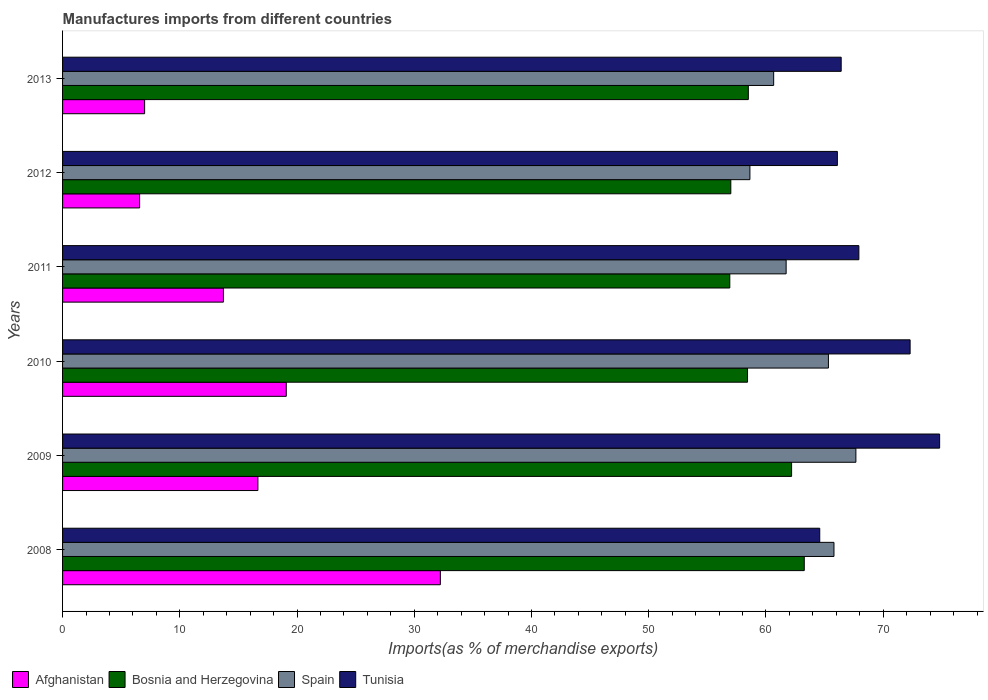How many different coloured bars are there?
Keep it short and to the point. 4. Are the number of bars on each tick of the Y-axis equal?
Make the answer very short. Yes. How many bars are there on the 4th tick from the bottom?
Your response must be concise. 4. What is the percentage of imports to different countries in Bosnia and Herzegovina in 2008?
Keep it short and to the point. 63.27. Across all years, what is the maximum percentage of imports to different countries in Afghanistan?
Make the answer very short. 32.23. Across all years, what is the minimum percentage of imports to different countries in Spain?
Your answer should be compact. 58.63. In which year was the percentage of imports to different countries in Bosnia and Herzegovina maximum?
Your answer should be very brief. 2008. In which year was the percentage of imports to different countries in Bosnia and Herzegovina minimum?
Offer a terse response. 2011. What is the total percentage of imports to different countries in Afghanistan in the graph?
Keep it short and to the point. 95.26. What is the difference between the percentage of imports to different countries in Tunisia in 2008 and that in 2009?
Provide a short and direct response. -10.23. What is the difference between the percentage of imports to different countries in Bosnia and Herzegovina in 2013 and the percentage of imports to different countries in Afghanistan in 2012?
Offer a terse response. 51.92. What is the average percentage of imports to different countries in Spain per year?
Offer a very short reply. 63.3. In the year 2009, what is the difference between the percentage of imports to different countries in Afghanistan and percentage of imports to different countries in Tunisia?
Ensure brevity in your answer.  -58.15. In how many years, is the percentage of imports to different countries in Afghanistan greater than 54 %?
Your answer should be very brief. 0. What is the ratio of the percentage of imports to different countries in Spain in 2009 to that in 2012?
Offer a very short reply. 1.15. Is the difference between the percentage of imports to different countries in Afghanistan in 2009 and 2013 greater than the difference between the percentage of imports to different countries in Tunisia in 2009 and 2013?
Give a very brief answer. Yes. What is the difference between the highest and the second highest percentage of imports to different countries in Spain?
Your answer should be compact. 1.87. What is the difference between the highest and the lowest percentage of imports to different countries in Spain?
Your answer should be compact. 9.04. In how many years, is the percentage of imports to different countries in Afghanistan greater than the average percentage of imports to different countries in Afghanistan taken over all years?
Offer a terse response. 3. Is the sum of the percentage of imports to different countries in Tunisia in 2010 and 2013 greater than the maximum percentage of imports to different countries in Spain across all years?
Your response must be concise. Yes. Is it the case that in every year, the sum of the percentage of imports to different countries in Afghanistan and percentage of imports to different countries in Bosnia and Herzegovina is greater than the sum of percentage of imports to different countries in Spain and percentage of imports to different countries in Tunisia?
Your answer should be very brief. No. What does the 4th bar from the top in 2010 represents?
Give a very brief answer. Afghanistan. Is it the case that in every year, the sum of the percentage of imports to different countries in Bosnia and Herzegovina and percentage of imports to different countries in Tunisia is greater than the percentage of imports to different countries in Spain?
Give a very brief answer. Yes. How many years are there in the graph?
Keep it short and to the point. 6. Are the values on the major ticks of X-axis written in scientific E-notation?
Your answer should be very brief. No. Does the graph contain grids?
Keep it short and to the point. No. Where does the legend appear in the graph?
Keep it short and to the point. Bottom left. How are the legend labels stacked?
Provide a succinct answer. Horizontal. What is the title of the graph?
Make the answer very short. Manufactures imports from different countries. What is the label or title of the X-axis?
Ensure brevity in your answer.  Imports(as % of merchandise exports). What is the Imports(as % of merchandise exports) of Afghanistan in 2008?
Your answer should be compact. 32.23. What is the Imports(as % of merchandise exports) of Bosnia and Herzegovina in 2008?
Offer a terse response. 63.27. What is the Imports(as % of merchandise exports) in Spain in 2008?
Ensure brevity in your answer.  65.8. What is the Imports(as % of merchandise exports) of Tunisia in 2008?
Your answer should be compact. 64.59. What is the Imports(as % of merchandise exports) in Afghanistan in 2009?
Offer a very short reply. 16.66. What is the Imports(as % of merchandise exports) in Bosnia and Herzegovina in 2009?
Ensure brevity in your answer.  62.19. What is the Imports(as % of merchandise exports) of Spain in 2009?
Make the answer very short. 67.67. What is the Imports(as % of merchandise exports) in Tunisia in 2009?
Offer a very short reply. 74.81. What is the Imports(as % of merchandise exports) in Afghanistan in 2010?
Provide a succinct answer. 19.08. What is the Imports(as % of merchandise exports) in Bosnia and Herzegovina in 2010?
Provide a succinct answer. 58.43. What is the Imports(as % of merchandise exports) in Spain in 2010?
Keep it short and to the point. 65.33. What is the Imports(as % of merchandise exports) in Tunisia in 2010?
Your response must be concise. 72.29. What is the Imports(as % of merchandise exports) in Afghanistan in 2011?
Provide a succinct answer. 13.72. What is the Imports(as % of merchandise exports) in Bosnia and Herzegovina in 2011?
Give a very brief answer. 56.91. What is the Imports(as % of merchandise exports) of Spain in 2011?
Offer a very short reply. 61.72. What is the Imports(as % of merchandise exports) in Tunisia in 2011?
Offer a very short reply. 67.92. What is the Imports(as % of merchandise exports) in Afghanistan in 2012?
Your answer should be very brief. 6.57. What is the Imports(as % of merchandise exports) in Bosnia and Herzegovina in 2012?
Offer a very short reply. 57. What is the Imports(as % of merchandise exports) of Spain in 2012?
Offer a terse response. 58.63. What is the Imports(as % of merchandise exports) of Tunisia in 2012?
Provide a succinct answer. 66.09. What is the Imports(as % of merchandise exports) in Afghanistan in 2013?
Offer a terse response. 7. What is the Imports(as % of merchandise exports) in Bosnia and Herzegovina in 2013?
Provide a short and direct response. 58.49. What is the Imports(as % of merchandise exports) in Spain in 2013?
Ensure brevity in your answer.  60.66. What is the Imports(as % of merchandise exports) of Tunisia in 2013?
Your answer should be very brief. 66.42. Across all years, what is the maximum Imports(as % of merchandise exports) of Afghanistan?
Give a very brief answer. 32.23. Across all years, what is the maximum Imports(as % of merchandise exports) in Bosnia and Herzegovina?
Offer a terse response. 63.27. Across all years, what is the maximum Imports(as % of merchandise exports) in Spain?
Ensure brevity in your answer.  67.67. Across all years, what is the maximum Imports(as % of merchandise exports) of Tunisia?
Provide a short and direct response. 74.81. Across all years, what is the minimum Imports(as % of merchandise exports) of Afghanistan?
Make the answer very short. 6.57. Across all years, what is the minimum Imports(as % of merchandise exports) of Bosnia and Herzegovina?
Keep it short and to the point. 56.91. Across all years, what is the minimum Imports(as % of merchandise exports) in Spain?
Your answer should be compact. 58.63. Across all years, what is the minimum Imports(as % of merchandise exports) in Tunisia?
Keep it short and to the point. 64.59. What is the total Imports(as % of merchandise exports) in Afghanistan in the graph?
Keep it short and to the point. 95.26. What is the total Imports(as % of merchandise exports) in Bosnia and Herzegovina in the graph?
Make the answer very short. 356.29. What is the total Imports(as % of merchandise exports) of Spain in the graph?
Make the answer very short. 379.8. What is the total Imports(as % of merchandise exports) of Tunisia in the graph?
Provide a short and direct response. 412.12. What is the difference between the Imports(as % of merchandise exports) of Afghanistan in 2008 and that in 2009?
Make the answer very short. 15.56. What is the difference between the Imports(as % of merchandise exports) in Bosnia and Herzegovina in 2008 and that in 2009?
Ensure brevity in your answer.  1.08. What is the difference between the Imports(as % of merchandise exports) of Spain in 2008 and that in 2009?
Offer a very short reply. -1.87. What is the difference between the Imports(as % of merchandise exports) in Tunisia in 2008 and that in 2009?
Your answer should be very brief. -10.23. What is the difference between the Imports(as % of merchandise exports) in Afghanistan in 2008 and that in 2010?
Provide a short and direct response. 13.14. What is the difference between the Imports(as % of merchandise exports) in Bosnia and Herzegovina in 2008 and that in 2010?
Offer a terse response. 4.84. What is the difference between the Imports(as % of merchandise exports) in Spain in 2008 and that in 2010?
Ensure brevity in your answer.  0.47. What is the difference between the Imports(as % of merchandise exports) in Tunisia in 2008 and that in 2010?
Your answer should be very brief. -7.71. What is the difference between the Imports(as % of merchandise exports) of Afghanistan in 2008 and that in 2011?
Ensure brevity in your answer.  18.5. What is the difference between the Imports(as % of merchandise exports) of Bosnia and Herzegovina in 2008 and that in 2011?
Your answer should be very brief. 6.35. What is the difference between the Imports(as % of merchandise exports) of Spain in 2008 and that in 2011?
Your answer should be very brief. 4.08. What is the difference between the Imports(as % of merchandise exports) in Tunisia in 2008 and that in 2011?
Make the answer very short. -3.34. What is the difference between the Imports(as % of merchandise exports) of Afghanistan in 2008 and that in 2012?
Your response must be concise. 25.65. What is the difference between the Imports(as % of merchandise exports) of Bosnia and Herzegovina in 2008 and that in 2012?
Your answer should be compact. 6.27. What is the difference between the Imports(as % of merchandise exports) in Spain in 2008 and that in 2012?
Offer a terse response. 7.17. What is the difference between the Imports(as % of merchandise exports) of Tunisia in 2008 and that in 2012?
Your response must be concise. -1.5. What is the difference between the Imports(as % of merchandise exports) in Afghanistan in 2008 and that in 2013?
Your answer should be compact. 25.23. What is the difference between the Imports(as % of merchandise exports) in Bosnia and Herzegovina in 2008 and that in 2013?
Keep it short and to the point. 4.77. What is the difference between the Imports(as % of merchandise exports) in Spain in 2008 and that in 2013?
Your answer should be very brief. 5.14. What is the difference between the Imports(as % of merchandise exports) in Tunisia in 2008 and that in 2013?
Provide a succinct answer. -1.83. What is the difference between the Imports(as % of merchandise exports) in Afghanistan in 2009 and that in 2010?
Give a very brief answer. -2.42. What is the difference between the Imports(as % of merchandise exports) in Bosnia and Herzegovina in 2009 and that in 2010?
Provide a short and direct response. 3.76. What is the difference between the Imports(as % of merchandise exports) of Spain in 2009 and that in 2010?
Make the answer very short. 2.34. What is the difference between the Imports(as % of merchandise exports) in Tunisia in 2009 and that in 2010?
Provide a succinct answer. 2.52. What is the difference between the Imports(as % of merchandise exports) in Afghanistan in 2009 and that in 2011?
Give a very brief answer. 2.94. What is the difference between the Imports(as % of merchandise exports) in Bosnia and Herzegovina in 2009 and that in 2011?
Offer a very short reply. 5.27. What is the difference between the Imports(as % of merchandise exports) in Spain in 2009 and that in 2011?
Your answer should be very brief. 5.95. What is the difference between the Imports(as % of merchandise exports) of Tunisia in 2009 and that in 2011?
Provide a succinct answer. 6.89. What is the difference between the Imports(as % of merchandise exports) in Afghanistan in 2009 and that in 2012?
Provide a short and direct response. 10.09. What is the difference between the Imports(as % of merchandise exports) of Bosnia and Herzegovina in 2009 and that in 2012?
Provide a short and direct response. 5.18. What is the difference between the Imports(as % of merchandise exports) of Spain in 2009 and that in 2012?
Ensure brevity in your answer.  9.04. What is the difference between the Imports(as % of merchandise exports) in Tunisia in 2009 and that in 2012?
Your answer should be compact. 8.72. What is the difference between the Imports(as % of merchandise exports) in Afghanistan in 2009 and that in 2013?
Make the answer very short. 9.66. What is the difference between the Imports(as % of merchandise exports) in Bosnia and Herzegovina in 2009 and that in 2013?
Offer a very short reply. 3.69. What is the difference between the Imports(as % of merchandise exports) of Spain in 2009 and that in 2013?
Provide a short and direct response. 7.01. What is the difference between the Imports(as % of merchandise exports) of Tunisia in 2009 and that in 2013?
Ensure brevity in your answer.  8.4. What is the difference between the Imports(as % of merchandise exports) in Afghanistan in 2010 and that in 2011?
Your answer should be very brief. 5.36. What is the difference between the Imports(as % of merchandise exports) of Bosnia and Herzegovina in 2010 and that in 2011?
Your answer should be compact. 1.51. What is the difference between the Imports(as % of merchandise exports) in Spain in 2010 and that in 2011?
Provide a succinct answer. 3.61. What is the difference between the Imports(as % of merchandise exports) of Tunisia in 2010 and that in 2011?
Make the answer very short. 4.37. What is the difference between the Imports(as % of merchandise exports) in Afghanistan in 2010 and that in 2012?
Your answer should be very brief. 12.51. What is the difference between the Imports(as % of merchandise exports) in Bosnia and Herzegovina in 2010 and that in 2012?
Give a very brief answer. 1.43. What is the difference between the Imports(as % of merchandise exports) in Spain in 2010 and that in 2012?
Offer a terse response. 6.7. What is the difference between the Imports(as % of merchandise exports) of Tunisia in 2010 and that in 2012?
Make the answer very short. 6.21. What is the difference between the Imports(as % of merchandise exports) in Afghanistan in 2010 and that in 2013?
Make the answer very short. 12.08. What is the difference between the Imports(as % of merchandise exports) in Bosnia and Herzegovina in 2010 and that in 2013?
Keep it short and to the point. -0.07. What is the difference between the Imports(as % of merchandise exports) in Spain in 2010 and that in 2013?
Your answer should be very brief. 4.67. What is the difference between the Imports(as % of merchandise exports) in Tunisia in 2010 and that in 2013?
Offer a terse response. 5.88. What is the difference between the Imports(as % of merchandise exports) of Afghanistan in 2011 and that in 2012?
Keep it short and to the point. 7.15. What is the difference between the Imports(as % of merchandise exports) in Bosnia and Herzegovina in 2011 and that in 2012?
Give a very brief answer. -0.09. What is the difference between the Imports(as % of merchandise exports) in Spain in 2011 and that in 2012?
Provide a short and direct response. 3.09. What is the difference between the Imports(as % of merchandise exports) of Tunisia in 2011 and that in 2012?
Your answer should be compact. 1.83. What is the difference between the Imports(as % of merchandise exports) of Afghanistan in 2011 and that in 2013?
Provide a succinct answer. 6.72. What is the difference between the Imports(as % of merchandise exports) in Bosnia and Herzegovina in 2011 and that in 2013?
Provide a short and direct response. -1.58. What is the difference between the Imports(as % of merchandise exports) in Spain in 2011 and that in 2013?
Your response must be concise. 1.06. What is the difference between the Imports(as % of merchandise exports) of Tunisia in 2011 and that in 2013?
Your answer should be compact. 1.51. What is the difference between the Imports(as % of merchandise exports) of Afghanistan in 2012 and that in 2013?
Make the answer very short. -0.43. What is the difference between the Imports(as % of merchandise exports) in Bosnia and Herzegovina in 2012 and that in 2013?
Your answer should be very brief. -1.49. What is the difference between the Imports(as % of merchandise exports) of Spain in 2012 and that in 2013?
Ensure brevity in your answer.  -2.03. What is the difference between the Imports(as % of merchandise exports) of Tunisia in 2012 and that in 2013?
Provide a succinct answer. -0.33. What is the difference between the Imports(as % of merchandise exports) of Afghanistan in 2008 and the Imports(as % of merchandise exports) of Bosnia and Herzegovina in 2009?
Your answer should be compact. -29.96. What is the difference between the Imports(as % of merchandise exports) in Afghanistan in 2008 and the Imports(as % of merchandise exports) in Spain in 2009?
Your answer should be very brief. -35.44. What is the difference between the Imports(as % of merchandise exports) in Afghanistan in 2008 and the Imports(as % of merchandise exports) in Tunisia in 2009?
Keep it short and to the point. -42.59. What is the difference between the Imports(as % of merchandise exports) of Bosnia and Herzegovina in 2008 and the Imports(as % of merchandise exports) of Spain in 2009?
Provide a short and direct response. -4.4. What is the difference between the Imports(as % of merchandise exports) in Bosnia and Herzegovina in 2008 and the Imports(as % of merchandise exports) in Tunisia in 2009?
Keep it short and to the point. -11.55. What is the difference between the Imports(as % of merchandise exports) in Spain in 2008 and the Imports(as % of merchandise exports) in Tunisia in 2009?
Provide a succinct answer. -9.01. What is the difference between the Imports(as % of merchandise exports) of Afghanistan in 2008 and the Imports(as % of merchandise exports) of Bosnia and Herzegovina in 2010?
Your response must be concise. -26.2. What is the difference between the Imports(as % of merchandise exports) in Afghanistan in 2008 and the Imports(as % of merchandise exports) in Spain in 2010?
Give a very brief answer. -33.1. What is the difference between the Imports(as % of merchandise exports) of Afghanistan in 2008 and the Imports(as % of merchandise exports) of Tunisia in 2010?
Your response must be concise. -40.07. What is the difference between the Imports(as % of merchandise exports) of Bosnia and Herzegovina in 2008 and the Imports(as % of merchandise exports) of Spain in 2010?
Offer a terse response. -2.06. What is the difference between the Imports(as % of merchandise exports) of Bosnia and Herzegovina in 2008 and the Imports(as % of merchandise exports) of Tunisia in 2010?
Ensure brevity in your answer.  -9.03. What is the difference between the Imports(as % of merchandise exports) of Spain in 2008 and the Imports(as % of merchandise exports) of Tunisia in 2010?
Offer a very short reply. -6.5. What is the difference between the Imports(as % of merchandise exports) of Afghanistan in 2008 and the Imports(as % of merchandise exports) of Bosnia and Herzegovina in 2011?
Provide a succinct answer. -24.69. What is the difference between the Imports(as % of merchandise exports) of Afghanistan in 2008 and the Imports(as % of merchandise exports) of Spain in 2011?
Ensure brevity in your answer.  -29.5. What is the difference between the Imports(as % of merchandise exports) of Afghanistan in 2008 and the Imports(as % of merchandise exports) of Tunisia in 2011?
Give a very brief answer. -35.7. What is the difference between the Imports(as % of merchandise exports) of Bosnia and Herzegovina in 2008 and the Imports(as % of merchandise exports) of Spain in 2011?
Your response must be concise. 1.55. What is the difference between the Imports(as % of merchandise exports) of Bosnia and Herzegovina in 2008 and the Imports(as % of merchandise exports) of Tunisia in 2011?
Ensure brevity in your answer.  -4.66. What is the difference between the Imports(as % of merchandise exports) of Spain in 2008 and the Imports(as % of merchandise exports) of Tunisia in 2011?
Your answer should be very brief. -2.12. What is the difference between the Imports(as % of merchandise exports) of Afghanistan in 2008 and the Imports(as % of merchandise exports) of Bosnia and Herzegovina in 2012?
Ensure brevity in your answer.  -24.78. What is the difference between the Imports(as % of merchandise exports) of Afghanistan in 2008 and the Imports(as % of merchandise exports) of Spain in 2012?
Give a very brief answer. -26.4. What is the difference between the Imports(as % of merchandise exports) in Afghanistan in 2008 and the Imports(as % of merchandise exports) in Tunisia in 2012?
Make the answer very short. -33.86. What is the difference between the Imports(as % of merchandise exports) of Bosnia and Herzegovina in 2008 and the Imports(as % of merchandise exports) of Spain in 2012?
Offer a terse response. 4.64. What is the difference between the Imports(as % of merchandise exports) in Bosnia and Herzegovina in 2008 and the Imports(as % of merchandise exports) in Tunisia in 2012?
Keep it short and to the point. -2.82. What is the difference between the Imports(as % of merchandise exports) of Spain in 2008 and the Imports(as % of merchandise exports) of Tunisia in 2012?
Ensure brevity in your answer.  -0.29. What is the difference between the Imports(as % of merchandise exports) of Afghanistan in 2008 and the Imports(as % of merchandise exports) of Bosnia and Herzegovina in 2013?
Your response must be concise. -26.27. What is the difference between the Imports(as % of merchandise exports) in Afghanistan in 2008 and the Imports(as % of merchandise exports) in Spain in 2013?
Provide a short and direct response. -28.43. What is the difference between the Imports(as % of merchandise exports) of Afghanistan in 2008 and the Imports(as % of merchandise exports) of Tunisia in 2013?
Your response must be concise. -34.19. What is the difference between the Imports(as % of merchandise exports) of Bosnia and Herzegovina in 2008 and the Imports(as % of merchandise exports) of Spain in 2013?
Offer a terse response. 2.61. What is the difference between the Imports(as % of merchandise exports) in Bosnia and Herzegovina in 2008 and the Imports(as % of merchandise exports) in Tunisia in 2013?
Offer a terse response. -3.15. What is the difference between the Imports(as % of merchandise exports) of Spain in 2008 and the Imports(as % of merchandise exports) of Tunisia in 2013?
Make the answer very short. -0.62. What is the difference between the Imports(as % of merchandise exports) in Afghanistan in 2009 and the Imports(as % of merchandise exports) in Bosnia and Herzegovina in 2010?
Make the answer very short. -41.76. What is the difference between the Imports(as % of merchandise exports) of Afghanistan in 2009 and the Imports(as % of merchandise exports) of Spain in 2010?
Keep it short and to the point. -48.66. What is the difference between the Imports(as % of merchandise exports) in Afghanistan in 2009 and the Imports(as % of merchandise exports) in Tunisia in 2010?
Your answer should be compact. -55.63. What is the difference between the Imports(as % of merchandise exports) in Bosnia and Herzegovina in 2009 and the Imports(as % of merchandise exports) in Spain in 2010?
Ensure brevity in your answer.  -3.14. What is the difference between the Imports(as % of merchandise exports) of Bosnia and Herzegovina in 2009 and the Imports(as % of merchandise exports) of Tunisia in 2010?
Your answer should be very brief. -10.11. What is the difference between the Imports(as % of merchandise exports) in Spain in 2009 and the Imports(as % of merchandise exports) in Tunisia in 2010?
Ensure brevity in your answer.  -4.63. What is the difference between the Imports(as % of merchandise exports) in Afghanistan in 2009 and the Imports(as % of merchandise exports) in Bosnia and Herzegovina in 2011?
Keep it short and to the point. -40.25. What is the difference between the Imports(as % of merchandise exports) in Afghanistan in 2009 and the Imports(as % of merchandise exports) in Spain in 2011?
Your answer should be very brief. -45.06. What is the difference between the Imports(as % of merchandise exports) of Afghanistan in 2009 and the Imports(as % of merchandise exports) of Tunisia in 2011?
Offer a terse response. -51.26. What is the difference between the Imports(as % of merchandise exports) of Bosnia and Herzegovina in 2009 and the Imports(as % of merchandise exports) of Spain in 2011?
Make the answer very short. 0.46. What is the difference between the Imports(as % of merchandise exports) in Bosnia and Herzegovina in 2009 and the Imports(as % of merchandise exports) in Tunisia in 2011?
Ensure brevity in your answer.  -5.74. What is the difference between the Imports(as % of merchandise exports) of Spain in 2009 and the Imports(as % of merchandise exports) of Tunisia in 2011?
Provide a short and direct response. -0.25. What is the difference between the Imports(as % of merchandise exports) in Afghanistan in 2009 and the Imports(as % of merchandise exports) in Bosnia and Herzegovina in 2012?
Offer a terse response. -40.34. What is the difference between the Imports(as % of merchandise exports) of Afghanistan in 2009 and the Imports(as % of merchandise exports) of Spain in 2012?
Your answer should be compact. -41.97. What is the difference between the Imports(as % of merchandise exports) in Afghanistan in 2009 and the Imports(as % of merchandise exports) in Tunisia in 2012?
Your answer should be very brief. -49.43. What is the difference between the Imports(as % of merchandise exports) of Bosnia and Herzegovina in 2009 and the Imports(as % of merchandise exports) of Spain in 2012?
Your answer should be compact. 3.56. What is the difference between the Imports(as % of merchandise exports) of Bosnia and Herzegovina in 2009 and the Imports(as % of merchandise exports) of Tunisia in 2012?
Provide a succinct answer. -3.9. What is the difference between the Imports(as % of merchandise exports) in Spain in 2009 and the Imports(as % of merchandise exports) in Tunisia in 2012?
Make the answer very short. 1.58. What is the difference between the Imports(as % of merchandise exports) of Afghanistan in 2009 and the Imports(as % of merchandise exports) of Bosnia and Herzegovina in 2013?
Your response must be concise. -41.83. What is the difference between the Imports(as % of merchandise exports) of Afghanistan in 2009 and the Imports(as % of merchandise exports) of Spain in 2013?
Give a very brief answer. -43.99. What is the difference between the Imports(as % of merchandise exports) of Afghanistan in 2009 and the Imports(as % of merchandise exports) of Tunisia in 2013?
Ensure brevity in your answer.  -49.75. What is the difference between the Imports(as % of merchandise exports) of Bosnia and Herzegovina in 2009 and the Imports(as % of merchandise exports) of Spain in 2013?
Provide a succinct answer. 1.53. What is the difference between the Imports(as % of merchandise exports) in Bosnia and Herzegovina in 2009 and the Imports(as % of merchandise exports) in Tunisia in 2013?
Your answer should be compact. -4.23. What is the difference between the Imports(as % of merchandise exports) of Spain in 2009 and the Imports(as % of merchandise exports) of Tunisia in 2013?
Your answer should be very brief. 1.25. What is the difference between the Imports(as % of merchandise exports) in Afghanistan in 2010 and the Imports(as % of merchandise exports) in Bosnia and Herzegovina in 2011?
Keep it short and to the point. -37.83. What is the difference between the Imports(as % of merchandise exports) of Afghanistan in 2010 and the Imports(as % of merchandise exports) of Spain in 2011?
Your response must be concise. -42.64. What is the difference between the Imports(as % of merchandise exports) in Afghanistan in 2010 and the Imports(as % of merchandise exports) in Tunisia in 2011?
Make the answer very short. -48.84. What is the difference between the Imports(as % of merchandise exports) in Bosnia and Herzegovina in 2010 and the Imports(as % of merchandise exports) in Spain in 2011?
Give a very brief answer. -3.29. What is the difference between the Imports(as % of merchandise exports) of Bosnia and Herzegovina in 2010 and the Imports(as % of merchandise exports) of Tunisia in 2011?
Give a very brief answer. -9.5. What is the difference between the Imports(as % of merchandise exports) of Spain in 2010 and the Imports(as % of merchandise exports) of Tunisia in 2011?
Your answer should be compact. -2.6. What is the difference between the Imports(as % of merchandise exports) of Afghanistan in 2010 and the Imports(as % of merchandise exports) of Bosnia and Herzegovina in 2012?
Give a very brief answer. -37.92. What is the difference between the Imports(as % of merchandise exports) of Afghanistan in 2010 and the Imports(as % of merchandise exports) of Spain in 2012?
Provide a succinct answer. -39.55. What is the difference between the Imports(as % of merchandise exports) in Afghanistan in 2010 and the Imports(as % of merchandise exports) in Tunisia in 2012?
Your answer should be compact. -47.01. What is the difference between the Imports(as % of merchandise exports) in Bosnia and Herzegovina in 2010 and the Imports(as % of merchandise exports) in Spain in 2012?
Ensure brevity in your answer.  -0.2. What is the difference between the Imports(as % of merchandise exports) of Bosnia and Herzegovina in 2010 and the Imports(as % of merchandise exports) of Tunisia in 2012?
Ensure brevity in your answer.  -7.66. What is the difference between the Imports(as % of merchandise exports) in Spain in 2010 and the Imports(as % of merchandise exports) in Tunisia in 2012?
Offer a very short reply. -0.76. What is the difference between the Imports(as % of merchandise exports) in Afghanistan in 2010 and the Imports(as % of merchandise exports) in Bosnia and Herzegovina in 2013?
Your response must be concise. -39.41. What is the difference between the Imports(as % of merchandise exports) of Afghanistan in 2010 and the Imports(as % of merchandise exports) of Spain in 2013?
Give a very brief answer. -41.57. What is the difference between the Imports(as % of merchandise exports) in Afghanistan in 2010 and the Imports(as % of merchandise exports) in Tunisia in 2013?
Give a very brief answer. -47.33. What is the difference between the Imports(as % of merchandise exports) in Bosnia and Herzegovina in 2010 and the Imports(as % of merchandise exports) in Spain in 2013?
Give a very brief answer. -2.23. What is the difference between the Imports(as % of merchandise exports) of Bosnia and Herzegovina in 2010 and the Imports(as % of merchandise exports) of Tunisia in 2013?
Keep it short and to the point. -7.99. What is the difference between the Imports(as % of merchandise exports) in Spain in 2010 and the Imports(as % of merchandise exports) in Tunisia in 2013?
Give a very brief answer. -1.09. What is the difference between the Imports(as % of merchandise exports) of Afghanistan in 2011 and the Imports(as % of merchandise exports) of Bosnia and Herzegovina in 2012?
Your response must be concise. -43.28. What is the difference between the Imports(as % of merchandise exports) in Afghanistan in 2011 and the Imports(as % of merchandise exports) in Spain in 2012?
Provide a succinct answer. -44.91. What is the difference between the Imports(as % of merchandise exports) in Afghanistan in 2011 and the Imports(as % of merchandise exports) in Tunisia in 2012?
Provide a succinct answer. -52.37. What is the difference between the Imports(as % of merchandise exports) of Bosnia and Herzegovina in 2011 and the Imports(as % of merchandise exports) of Spain in 2012?
Your response must be concise. -1.72. What is the difference between the Imports(as % of merchandise exports) in Bosnia and Herzegovina in 2011 and the Imports(as % of merchandise exports) in Tunisia in 2012?
Offer a very short reply. -9.18. What is the difference between the Imports(as % of merchandise exports) of Spain in 2011 and the Imports(as % of merchandise exports) of Tunisia in 2012?
Offer a very short reply. -4.37. What is the difference between the Imports(as % of merchandise exports) of Afghanistan in 2011 and the Imports(as % of merchandise exports) of Bosnia and Herzegovina in 2013?
Your answer should be very brief. -44.77. What is the difference between the Imports(as % of merchandise exports) of Afghanistan in 2011 and the Imports(as % of merchandise exports) of Spain in 2013?
Keep it short and to the point. -46.94. What is the difference between the Imports(as % of merchandise exports) of Afghanistan in 2011 and the Imports(as % of merchandise exports) of Tunisia in 2013?
Keep it short and to the point. -52.7. What is the difference between the Imports(as % of merchandise exports) of Bosnia and Herzegovina in 2011 and the Imports(as % of merchandise exports) of Spain in 2013?
Give a very brief answer. -3.74. What is the difference between the Imports(as % of merchandise exports) in Bosnia and Herzegovina in 2011 and the Imports(as % of merchandise exports) in Tunisia in 2013?
Offer a terse response. -9.5. What is the difference between the Imports(as % of merchandise exports) of Spain in 2011 and the Imports(as % of merchandise exports) of Tunisia in 2013?
Ensure brevity in your answer.  -4.7. What is the difference between the Imports(as % of merchandise exports) of Afghanistan in 2012 and the Imports(as % of merchandise exports) of Bosnia and Herzegovina in 2013?
Offer a very short reply. -51.92. What is the difference between the Imports(as % of merchandise exports) in Afghanistan in 2012 and the Imports(as % of merchandise exports) in Spain in 2013?
Keep it short and to the point. -54.08. What is the difference between the Imports(as % of merchandise exports) of Afghanistan in 2012 and the Imports(as % of merchandise exports) of Tunisia in 2013?
Your response must be concise. -59.84. What is the difference between the Imports(as % of merchandise exports) of Bosnia and Herzegovina in 2012 and the Imports(as % of merchandise exports) of Spain in 2013?
Offer a terse response. -3.66. What is the difference between the Imports(as % of merchandise exports) in Bosnia and Herzegovina in 2012 and the Imports(as % of merchandise exports) in Tunisia in 2013?
Keep it short and to the point. -9.42. What is the difference between the Imports(as % of merchandise exports) in Spain in 2012 and the Imports(as % of merchandise exports) in Tunisia in 2013?
Provide a succinct answer. -7.79. What is the average Imports(as % of merchandise exports) in Afghanistan per year?
Provide a short and direct response. 15.88. What is the average Imports(as % of merchandise exports) of Bosnia and Herzegovina per year?
Your answer should be compact. 59.38. What is the average Imports(as % of merchandise exports) in Spain per year?
Offer a terse response. 63.3. What is the average Imports(as % of merchandise exports) of Tunisia per year?
Keep it short and to the point. 68.69. In the year 2008, what is the difference between the Imports(as % of merchandise exports) in Afghanistan and Imports(as % of merchandise exports) in Bosnia and Herzegovina?
Your response must be concise. -31.04. In the year 2008, what is the difference between the Imports(as % of merchandise exports) of Afghanistan and Imports(as % of merchandise exports) of Spain?
Make the answer very short. -33.57. In the year 2008, what is the difference between the Imports(as % of merchandise exports) in Afghanistan and Imports(as % of merchandise exports) in Tunisia?
Your answer should be very brief. -32.36. In the year 2008, what is the difference between the Imports(as % of merchandise exports) of Bosnia and Herzegovina and Imports(as % of merchandise exports) of Spain?
Provide a succinct answer. -2.53. In the year 2008, what is the difference between the Imports(as % of merchandise exports) of Bosnia and Herzegovina and Imports(as % of merchandise exports) of Tunisia?
Your response must be concise. -1.32. In the year 2008, what is the difference between the Imports(as % of merchandise exports) of Spain and Imports(as % of merchandise exports) of Tunisia?
Make the answer very short. 1.21. In the year 2009, what is the difference between the Imports(as % of merchandise exports) in Afghanistan and Imports(as % of merchandise exports) in Bosnia and Herzegovina?
Keep it short and to the point. -45.52. In the year 2009, what is the difference between the Imports(as % of merchandise exports) in Afghanistan and Imports(as % of merchandise exports) in Spain?
Your answer should be compact. -51.01. In the year 2009, what is the difference between the Imports(as % of merchandise exports) of Afghanistan and Imports(as % of merchandise exports) of Tunisia?
Provide a succinct answer. -58.15. In the year 2009, what is the difference between the Imports(as % of merchandise exports) in Bosnia and Herzegovina and Imports(as % of merchandise exports) in Spain?
Offer a terse response. -5.48. In the year 2009, what is the difference between the Imports(as % of merchandise exports) in Bosnia and Herzegovina and Imports(as % of merchandise exports) in Tunisia?
Your response must be concise. -12.63. In the year 2009, what is the difference between the Imports(as % of merchandise exports) in Spain and Imports(as % of merchandise exports) in Tunisia?
Keep it short and to the point. -7.14. In the year 2010, what is the difference between the Imports(as % of merchandise exports) in Afghanistan and Imports(as % of merchandise exports) in Bosnia and Herzegovina?
Ensure brevity in your answer.  -39.34. In the year 2010, what is the difference between the Imports(as % of merchandise exports) in Afghanistan and Imports(as % of merchandise exports) in Spain?
Provide a succinct answer. -46.24. In the year 2010, what is the difference between the Imports(as % of merchandise exports) of Afghanistan and Imports(as % of merchandise exports) of Tunisia?
Offer a very short reply. -53.21. In the year 2010, what is the difference between the Imports(as % of merchandise exports) in Bosnia and Herzegovina and Imports(as % of merchandise exports) in Spain?
Provide a short and direct response. -6.9. In the year 2010, what is the difference between the Imports(as % of merchandise exports) in Bosnia and Herzegovina and Imports(as % of merchandise exports) in Tunisia?
Offer a terse response. -13.87. In the year 2010, what is the difference between the Imports(as % of merchandise exports) of Spain and Imports(as % of merchandise exports) of Tunisia?
Your answer should be very brief. -6.97. In the year 2011, what is the difference between the Imports(as % of merchandise exports) in Afghanistan and Imports(as % of merchandise exports) in Bosnia and Herzegovina?
Your answer should be compact. -43.19. In the year 2011, what is the difference between the Imports(as % of merchandise exports) of Afghanistan and Imports(as % of merchandise exports) of Spain?
Give a very brief answer. -48. In the year 2011, what is the difference between the Imports(as % of merchandise exports) in Afghanistan and Imports(as % of merchandise exports) in Tunisia?
Offer a terse response. -54.2. In the year 2011, what is the difference between the Imports(as % of merchandise exports) of Bosnia and Herzegovina and Imports(as % of merchandise exports) of Spain?
Provide a short and direct response. -4.81. In the year 2011, what is the difference between the Imports(as % of merchandise exports) of Bosnia and Herzegovina and Imports(as % of merchandise exports) of Tunisia?
Your response must be concise. -11.01. In the year 2011, what is the difference between the Imports(as % of merchandise exports) of Spain and Imports(as % of merchandise exports) of Tunisia?
Ensure brevity in your answer.  -6.2. In the year 2012, what is the difference between the Imports(as % of merchandise exports) of Afghanistan and Imports(as % of merchandise exports) of Bosnia and Herzegovina?
Offer a terse response. -50.43. In the year 2012, what is the difference between the Imports(as % of merchandise exports) of Afghanistan and Imports(as % of merchandise exports) of Spain?
Give a very brief answer. -52.05. In the year 2012, what is the difference between the Imports(as % of merchandise exports) of Afghanistan and Imports(as % of merchandise exports) of Tunisia?
Provide a succinct answer. -59.52. In the year 2012, what is the difference between the Imports(as % of merchandise exports) in Bosnia and Herzegovina and Imports(as % of merchandise exports) in Spain?
Make the answer very short. -1.63. In the year 2012, what is the difference between the Imports(as % of merchandise exports) of Bosnia and Herzegovina and Imports(as % of merchandise exports) of Tunisia?
Offer a terse response. -9.09. In the year 2012, what is the difference between the Imports(as % of merchandise exports) of Spain and Imports(as % of merchandise exports) of Tunisia?
Your answer should be compact. -7.46. In the year 2013, what is the difference between the Imports(as % of merchandise exports) in Afghanistan and Imports(as % of merchandise exports) in Bosnia and Herzegovina?
Provide a succinct answer. -51.49. In the year 2013, what is the difference between the Imports(as % of merchandise exports) of Afghanistan and Imports(as % of merchandise exports) of Spain?
Provide a succinct answer. -53.66. In the year 2013, what is the difference between the Imports(as % of merchandise exports) of Afghanistan and Imports(as % of merchandise exports) of Tunisia?
Offer a very short reply. -59.42. In the year 2013, what is the difference between the Imports(as % of merchandise exports) in Bosnia and Herzegovina and Imports(as % of merchandise exports) in Spain?
Give a very brief answer. -2.16. In the year 2013, what is the difference between the Imports(as % of merchandise exports) in Bosnia and Herzegovina and Imports(as % of merchandise exports) in Tunisia?
Give a very brief answer. -7.92. In the year 2013, what is the difference between the Imports(as % of merchandise exports) in Spain and Imports(as % of merchandise exports) in Tunisia?
Offer a terse response. -5.76. What is the ratio of the Imports(as % of merchandise exports) of Afghanistan in 2008 to that in 2009?
Give a very brief answer. 1.93. What is the ratio of the Imports(as % of merchandise exports) of Bosnia and Herzegovina in 2008 to that in 2009?
Ensure brevity in your answer.  1.02. What is the ratio of the Imports(as % of merchandise exports) in Spain in 2008 to that in 2009?
Provide a short and direct response. 0.97. What is the ratio of the Imports(as % of merchandise exports) in Tunisia in 2008 to that in 2009?
Keep it short and to the point. 0.86. What is the ratio of the Imports(as % of merchandise exports) of Afghanistan in 2008 to that in 2010?
Your response must be concise. 1.69. What is the ratio of the Imports(as % of merchandise exports) in Bosnia and Herzegovina in 2008 to that in 2010?
Give a very brief answer. 1.08. What is the ratio of the Imports(as % of merchandise exports) of Spain in 2008 to that in 2010?
Your answer should be very brief. 1.01. What is the ratio of the Imports(as % of merchandise exports) of Tunisia in 2008 to that in 2010?
Your response must be concise. 0.89. What is the ratio of the Imports(as % of merchandise exports) in Afghanistan in 2008 to that in 2011?
Your response must be concise. 2.35. What is the ratio of the Imports(as % of merchandise exports) of Bosnia and Herzegovina in 2008 to that in 2011?
Offer a terse response. 1.11. What is the ratio of the Imports(as % of merchandise exports) of Spain in 2008 to that in 2011?
Provide a succinct answer. 1.07. What is the ratio of the Imports(as % of merchandise exports) in Tunisia in 2008 to that in 2011?
Your answer should be compact. 0.95. What is the ratio of the Imports(as % of merchandise exports) of Afghanistan in 2008 to that in 2012?
Your answer should be very brief. 4.9. What is the ratio of the Imports(as % of merchandise exports) of Bosnia and Herzegovina in 2008 to that in 2012?
Your answer should be very brief. 1.11. What is the ratio of the Imports(as % of merchandise exports) in Spain in 2008 to that in 2012?
Your answer should be compact. 1.12. What is the ratio of the Imports(as % of merchandise exports) in Tunisia in 2008 to that in 2012?
Provide a short and direct response. 0.98. What is the ratio of the Imports(as % of merchandise exports) in Afghanistan in 2008 to that in 2013?
Offer a very short reply. 4.6. What is the ratio of the Imports(as % of merchandise exports) of Bosnia and Herzegovina in 2008 to that in 2013?
Your response must be concise. 1.08. What is the ratio of the Imports(as % of merchandise exports) in Spain in 2008 to that in 2013?
Make the answer very short. 1.08. What is the ratio of the Imports(as % of merchandise exports) in Tunisia in 2008 to that in 2013?
Make the answer very short. 0.97. What is the ratio of the Imports(as % of merchandise exports) in Afghanistan in 2009 to that in 2010?
Provide a short and direct response. 0.87. What is the ratio of the Imports(as % of merchandise exports) of Bosnia and Herzegovina in 2009 to that in 2010?
Your answer should be very brief. 1.06. What is the ratio of the Imports(as % of merchandise exports) of Spain in 2009 to that in 2010?
Keep it short and to the point. 1.04. What is the ratio of the Imports(as % of merchandise exports) in Tunisia in 2009 to that in 2010?
Offer a terse response. 1.03. What is the ratio of the Imports(as % of merchandise exports) in Afghanistan in 2009 to that in 2011?
Keep it short and to the point. 1.21. What is the ratio of the Imports(as % of merchandise exports) in Bosnia and Herzegovina in 2009 to that in 2011?
Keep it short and to the point. 1.09. What is the ratio of the Imports(as % of merchandise exports) in Spain in 2009 to that in 2011?
Offer a very short reply. 1.1. What is the ratio of the Imports(as % of merchandise exports) of Tunisia in 2009 to that in 2011?
Make the answer very short. 1.1. What is the ratio of the Imports(as % of merchandise exports) of Afghanistan in 2009 to that in 2012?
Ensure brevity in your answer.  2.53. What is the ratio of the Imports(as % of merchandise exports) in Bosnia and Herzegovina in 2009 to that in 2012?
Your response must be concise. 1.09. What is the ratio of the Imports(as % of merchandise exports) of Spain in 2009 to that in 2012?
Your response must be concise. 1.15. What is the ratio of the Imports(as % of merchandise exports) of Tunisia in 2009 to that in 2012?
Offer a terse response. 1.13. What is the ratio of the Imports(as % of merchandise exports) of Afghanistan in 2009 to that in 2013?
Ensure brevity in your answer.  2.38. What is the ratio of the Imports(as % of merchandise exports) of Bosnia and Herzegovina in 2009 to that in 2013?
Your answer should be very brief. 1.06. What is the ratio of the Imports(as % of merchandise exports) in Spain in 2009 to that in 2013?
Your answer should be compact. 1.12. What is the ratio of the Imports(as % of merchandise exports) of Tunisia in 2009 to that in 2013?
Your answer should be very brief. 1.13. What is the ratio of the Imports(as % of merchandise exports) in Afghanistan in 2010 to that in 2011?
Make the answer very short. 1.39. What is the ratio of the Imports(as % of merchandise exports) in Bosnia and Herzegovina in 2010 to that in 2011?
Provide a succinct answer. 1.03. What is the ratio of the Imports(as % of merchandise exports) in Spain in 2010 to that in 2011?
Keep it short and to the point. 1.06. What is the ratio of the Imports(as % of merchandise exports) in Tunisia in 2010 to that in 2011?
Your answer should be very brief. 1.06. What is the ratio of the Imports(as % of merchandise exports) in Afghanistan in 2010 to that in 2012?
Offer a terse response. 2.9. What is the ratio of the Imports(as % of merchandise exports) in Spain in 2010 to that in 2012?
Your answer should be very brief. 1.11. What is the ratio of the Imports(as % of merchandise exports) in Tunisia in 2010 to that in 2012?
Provide a short and direct response. 1.09. What is the ratio of the Imports(as % of merchandise exports) of Afghanistan in 2010 to that in 2013?
Ensure brevity in your answer.  2.73. What is the ratio of the Imports(as % of merchandise exports) in Bosnia and Herzegovina in 2010 to that in 2013?
Your answer should be very brief. 1. What is the ratio of the Imports(as % of merchandise exports) in Spain in 2010 to that in 2013?
Provide a succinct answer. 1.08. What is the ratio of the Imports(as % of merchandise exports) in Tunisia in 2010 to that in 2013?
Your response must be concise. 1.09. What is the ratio of the Imports(as % of merchandise exports) in Afghanistan in 2011 to that in 2012?
Your answer should be compact. 2.09. What is the ratio of the Imports(as % of merchandise exports) in Bosnia and Herzegovina in 2011 to that in 2012?
Make the answer very short. 1. What is the ratio of the Imports(as % of merchandise exports) of Spain in 2011 to that in 2012?
Provide a succinct answer. 1.05. What is the ratio of the Imports(as % of merchandise exports) in Tunisia in 2011 to that in 2012?
Make the answer very short. 1.03. What is the ratio of the Imports(as % of merchandise exports) of Afghanistan in 2011 to that in 2013?
Offer a very short reply. 1.96. What is the ratio of the Imports(as % of merchandise exports) of Bosnia and Herzegovina in 2011 to that in 2013?
Provide a succinct answer. 0.97. What is the ratio of the Imports(as % of merchandise exports) in Spain in 2011 to that in 2013?
Give a very brief answer. 1.02. What is the ratio of the Imports(as % of merchandise exports) in Tunisia in 2011 to that in 2013?
Make the answer very short. 1.02. What is the ratio of the Imports(as % of merchandise exports) in Afghanistan in 2012 to that in 2013?
Provide a succinct answer. 0.94. What is the ratio of the Imports(as % of merchandise exports) of Bosnia and Herzegovina in 2012 to that in 2013?
Give a very brief answer. 0.97. What is the ratio of the Imports(as % of merchandise exports) in Spain in 2012 to that in 2013?
Make the answer very short. 0.97. What is the difference between the highest and the second highest Imports(as % of merchandise exports) of Afghanistan?
Your answer should be compact. 13.14. What is the difference between the highest and the second highest Imports(as % of merchandise exports) in Bosnia and Herzegovina?
Give a very brief answer. 1.08. What is the difference between the highest and the second highest Imports(as % of merchandise exports) of Spain?
Ensure brevity in your answer.  1.87. What is the difference between the highest and the second highest Imports(as % of merchandise exports) of Tunisia?
Provide a succinct answer. 2.52. What is the difference between the highest and the lowest Imports(as % of merchandise exports) in Afghanistan?
Make the answer very short. 25.65. What is the difference between the highest and the lowest Imports(as % of merchandise exports) in Bosnia and Herzegovina?
Your answer should be very brief. 6.35. What is the difference between the highest and the lowest Imports(as % of merchandise exports) of Spain?
Provide a succinct answer. 9.04. What is the difference between the highest and the lowest Imports(as % of merchandise exports) of Tunisia?
Provide a short and direct response. 10.23. 